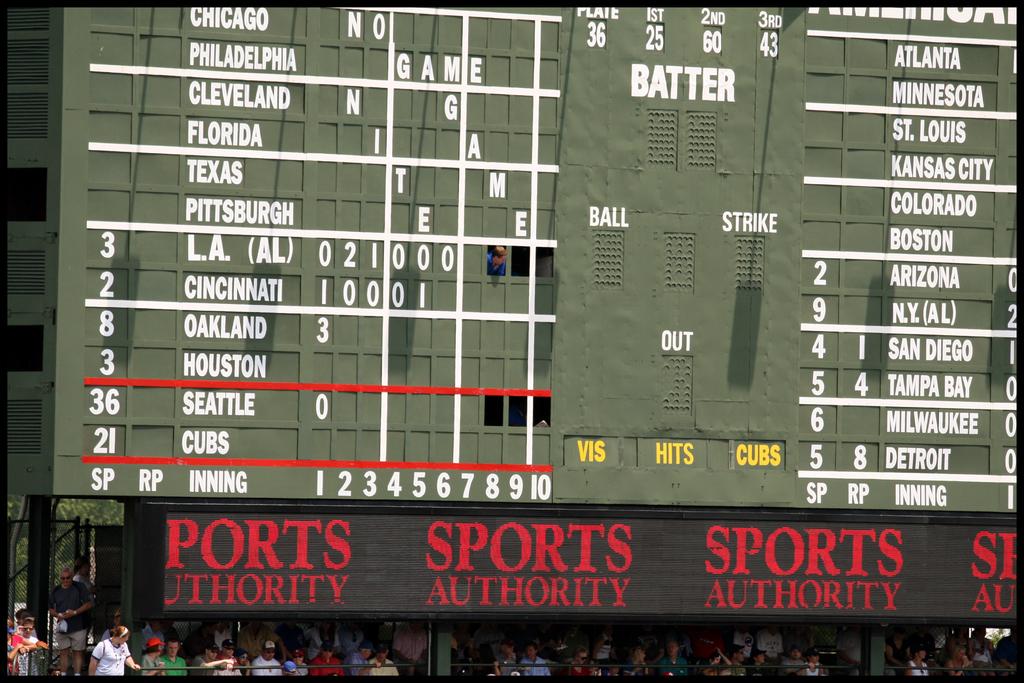What sponsor do you see?
Keep it short and to the point. Sports authority. 